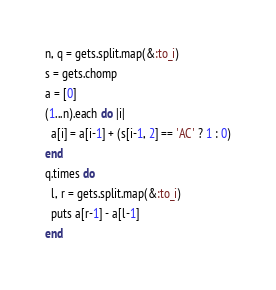Convert code to text. <code><loc_0><loc_0><loc_500><loc_500><_Ruby_>n, q = gets.split.map(&:to_i)
s = gets.chomp
a = [0]
(1...n).each do |i|
  a[i] = a[i-1] + (s[i-1, 2] == 'AC' ? 1 : 0)
end
q.times do
  l, r = gets.split.map(&:to_i)
  puts a[r-1] - a[l-1]
end</code> 